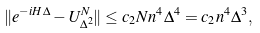Convert formula to latex. <formula><loc_0><loc_0><loc_500><loc_500>\| e ^ { - i H \Delta } - U _ { \Delta ^ { 2 } } ^ { N } \| \leq c _ { 2 } N n ^ { 4 } \Delta ^ { 4 } = c _ { 2 } n ^ { 4 } \Delta ^ { 3 } ,</formula> 